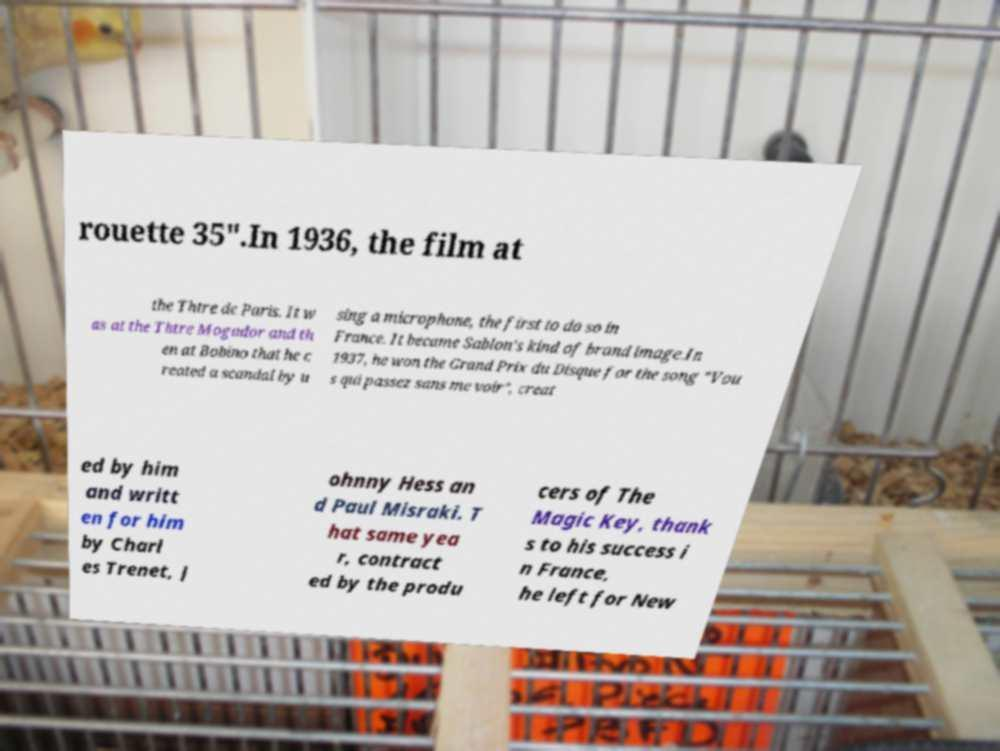Can you accurately transcribe the text from the provided image for me? rouette 35".In 1936, the film at the Thtre de Paris. It w as at the Thtre Mogador and th en at Bobino that he c reated a scandal by u sing a microphone, the first to do so in France. It became Sablon's kind of brand image.In 1937, he won the Grand Prix du Disque for the song "Vou s qui passez sans me voir", creat ed by him and writt en for him by Charl es Trenet, J ohnny Hess an d Paul Misraki. T hat same yea r, contract ed by the produ cers of The Magic Key, thank s to his success i n France, he left for New 